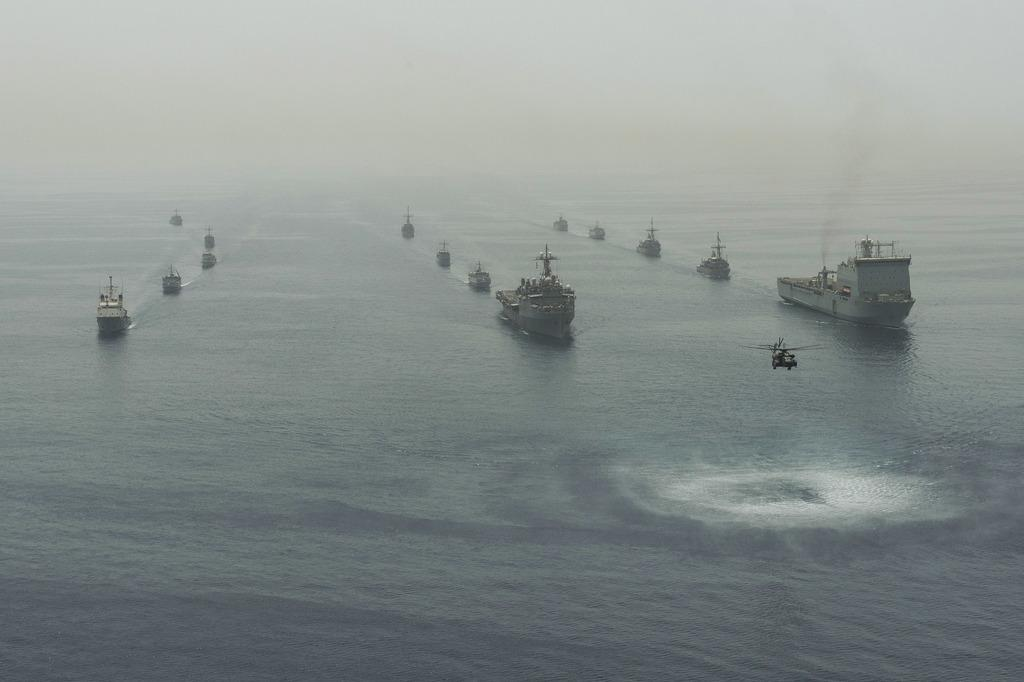What is the main setting of the image? There is an ocean in the image. What types of vehicles can be seen in the ocean? There are boats in the ocean. What other mode of transportation is present in the image? There is a helicopter in the image. Where is the tub located in the image? There is no tub present in the image. Can you see any windows on the boats in the image? The provided facts do not mention any windows on the boats, so we cannot determine their presence from the image. --- 